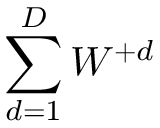Convert formula to latex. <formula><loc_0><loc_0><loc_500><loc_500>\sum _ { d = 1 } ^ { D } W ^ { + d }</formula> 